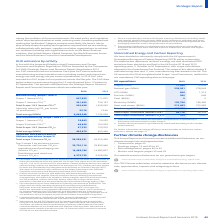According to Unilever Plc's financial document, How is the carbon emission factor for grid calculated? Based on the financial document, the answer is Carbon emission factors for grid electricity calculated according to the marketbased method'. Also, UK accounts for what percentage of Total Scope 1 and 2? According to the financial document, 5%. The relevant text states: "cturing sites based in the UK. The UK accounts for 5% of our global total Scope 1 and 2 emissions, outlined in our mandatory GHG reporting also on this pa..." Also, In which scope is transportation included? According to the financial document, Scope 3. The relevant text states: "Upstream and downstream of Unilever operations (scope 3)..." Also, can you calculate: What is the increase in the Biogas from 2018 to 2019? Based on the calculation: 17,045 - 15,958, the result is 1087. This is based on the information: "Biogas (MWh) 17,045 15,958 Biogas (MWh) 17,045 15,958..." The key data points involved are: 15,958, 17,045. Also, can you calculate: What is the average total energy? To answer this question, I need to perform calculations using the financial data. The calculation is: (408,280 + 469,950) / 2, which equals 439115. This is based on the information: "Total energy (MWh) (a) 408,280 469,950 Total energy (MWh) (a) 408,280 469,950..." The key data points involved are: 408,280, 469,950. Also, can you calculate: What is the percentage increase / (decrease) in Fuel Oils from 2018 to 2019? To answer this question, I need to perform calculations using the financial data. The calculation is: 580 / 648 - 1, which equals -10.49 (percentage). This is based on the information: "Fuel oils (MWh) 580 648 Fuel oils (MWh) 580 648..." The key data points involved are: 580, 648. 